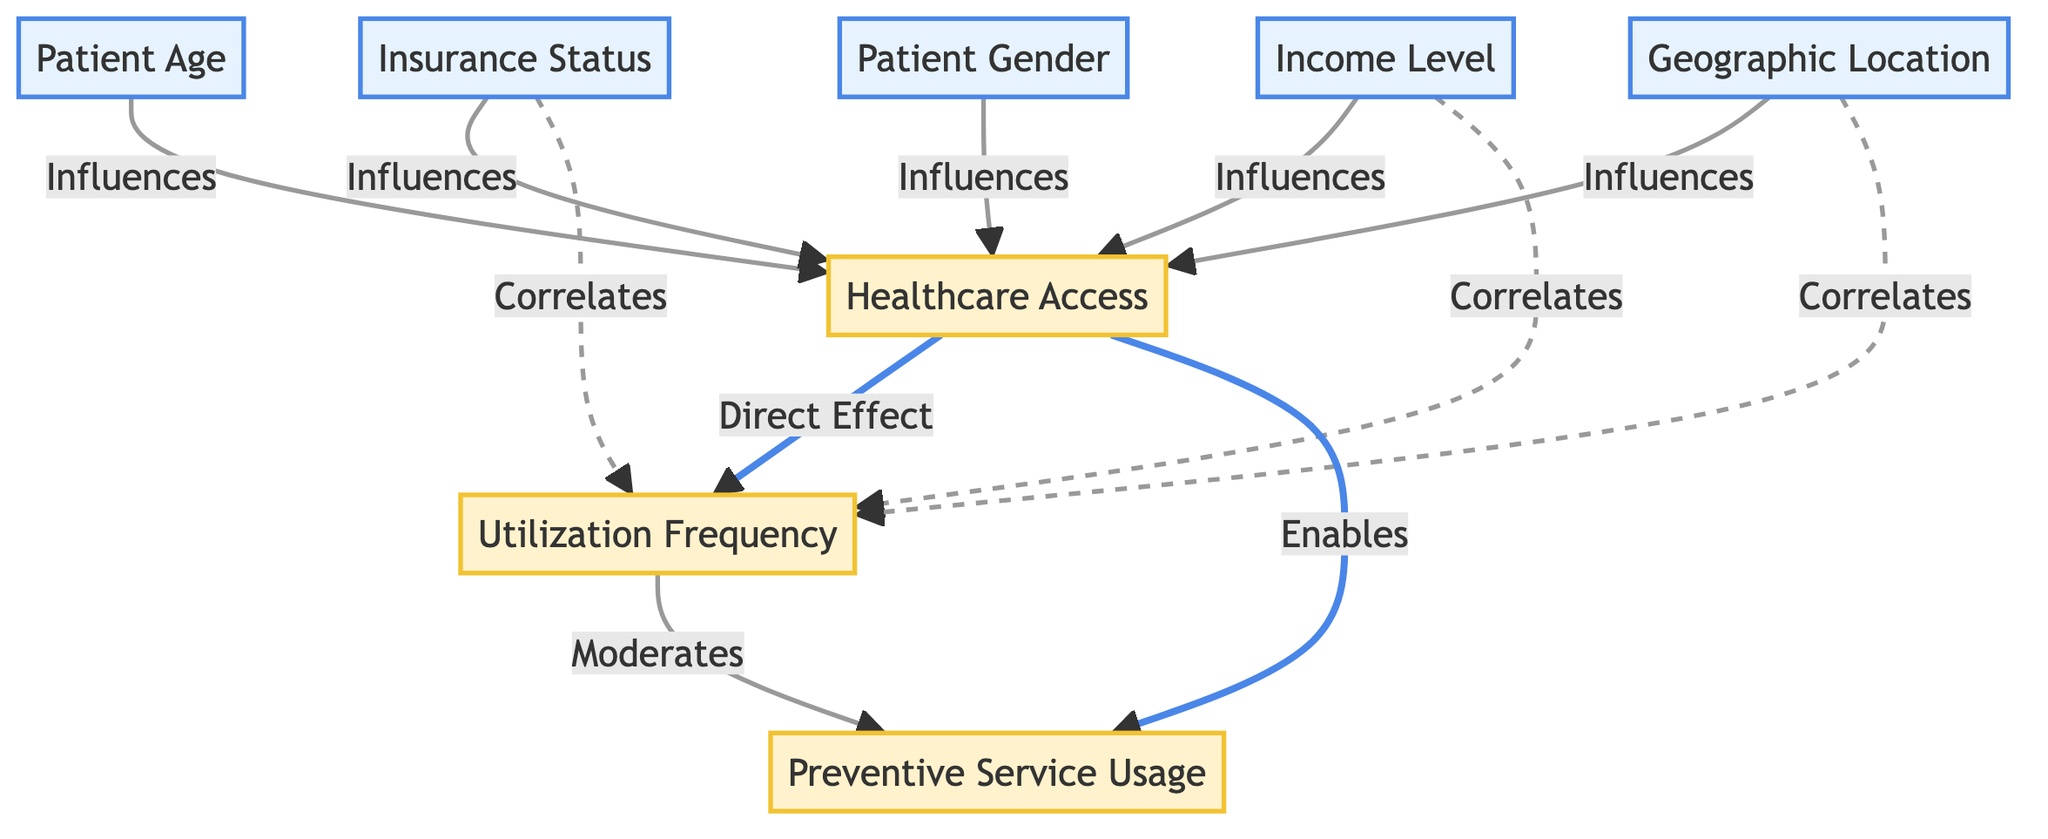What nodes influence healthcare access? The nodes that influence healthcare access are Patient Age, Patient Gender, Insurance Status, Income Level, and Geographic Location. This can be seen from the directed edges leading into the healthcare access node in the diagram.
Answer: Patient Age, Patient Gender, Insurance Status, Income Level, Geographic Location How many demographic nodes are present in the diagram? There are five demographic nodes represented in the diagram: Patient Age, Patient Gender, Insurance Status, Income Level, and Geographic Location. Counting these nodes gives us the total of five.
Answer: Five What is the direct effect of healthcare access in the diagram? The direct effect of healthcare access, as indicated by the arrows pointing from the healthcare access node, is to enable Preventive Service Usage and also directly influence Utilization Frequency.
Answer: Utilization Frequency, Preventive Service Usage Which node correlates with utilization frequency? The nodes that correlate with utilization frequency are Insurance Status, Income Level, and Geographic Location, shown by the dashed arrows indicating correlation.
Answer: Insurance Status, Income Level, Geographic Location What does utilization frequency moderate? According to the diagram, utilization frequency moderates preventive service usage, as depicted by the directed arrow pointing from utilization frequency to preventive service usage.
Answer: Preventive Service Usage How many influences are there on healthcare access? The diagram shows five influences on healthcare access, as indicated by the arrows leading to the healthcare access node. Each of the five demographic nodes points to this node.
Answer: Five Which demographic factor has the potential to affect both healthcare access and utilization frequency? Insurance Status is the demographic factor that influences healthcare access and also correlates with utilization frequency, as indicated by the respective arrows.
Answer: Insurance Status What type of relationship exists between healthcare access and preventive service usage? The relationship between healthcare access and preventive service usage is that healthcare access enables preventive service usage, as shown by the directed arrow from healthcare access to preventive service usage.
Answer: Enables 